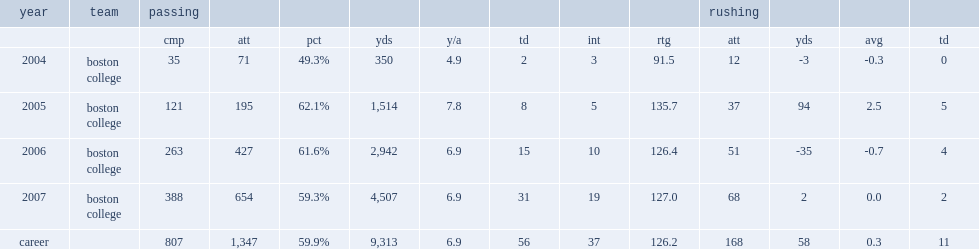How many interceptions did matt ryan complete in 2006? 10.0. 